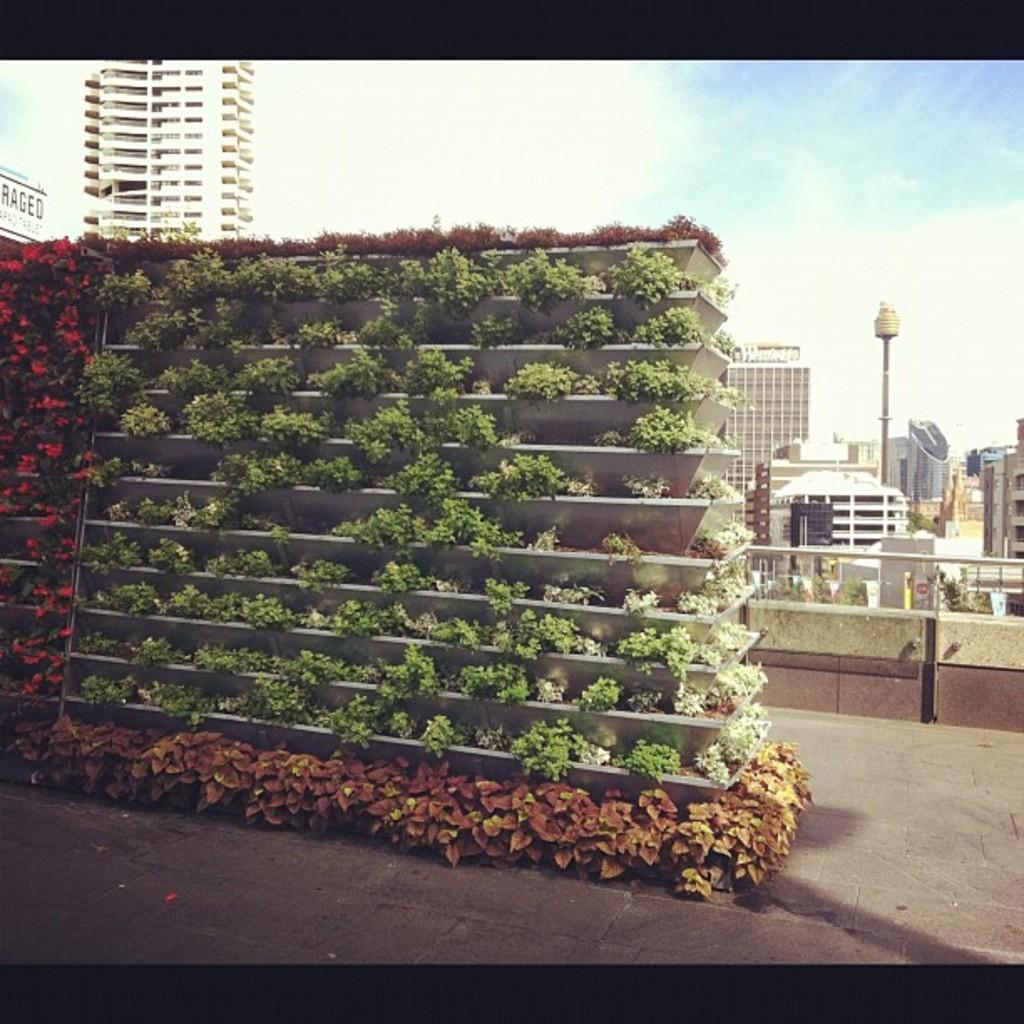What type of structures can be seen in the image? There are buildings in the image. What object is present in the image that is typically used for support or signage? There is a pole in the image. What type of vegetation is visible in the image, and where are they located? There are plants in shelves in the image. How would you describe the sky in the image? The sky is blue and cloudy in the image. What type of hydrant can be seen in the image? There is no hydrant present in the image. What religious symbols or practices are depicted in the image? There are no religious symbols or practices depicted in the image. 